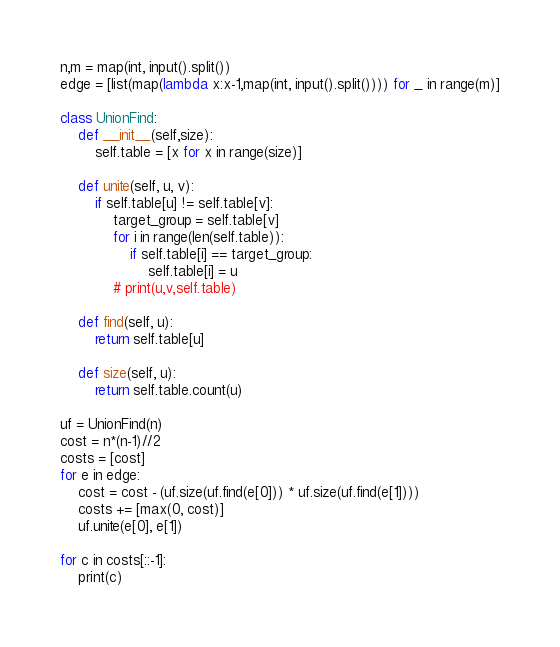<code> <loc_0><loc_0><loc_500><loc_500><_Python_>n,m = map(int, input().split())
edge = [list(map(lambda x:x-1,map(int, input().split()))) for _ in range(m)]

class UnionFind:
    def __init__(self,size):
        self.table = [x for x in range(size)]
        
    def unite(self, u, v):
        if self.table[u] != self.table[v]:
            target_group = self.table[v]
            for i in range(len(self.table)):
                if self.table[i] == target_group:
                    self.table[i] = u
            # print(u,v,self.table)

    def find(self, u):
        return self.table[u]

    def size(self, u):
        return self.table.count(u)

uf = UnionFind(n)
cost = n*(n-1)//2
costs = [cost]
for e in edge:
    cost = cost - (uf.size(uf.find(e[0])) * uf.size(uf.find(e[1])))
    costs += [max(0, cost)]
    uf.unite(e[0], e[1])

for c in costs[::-1]:
    print(c)</code> 